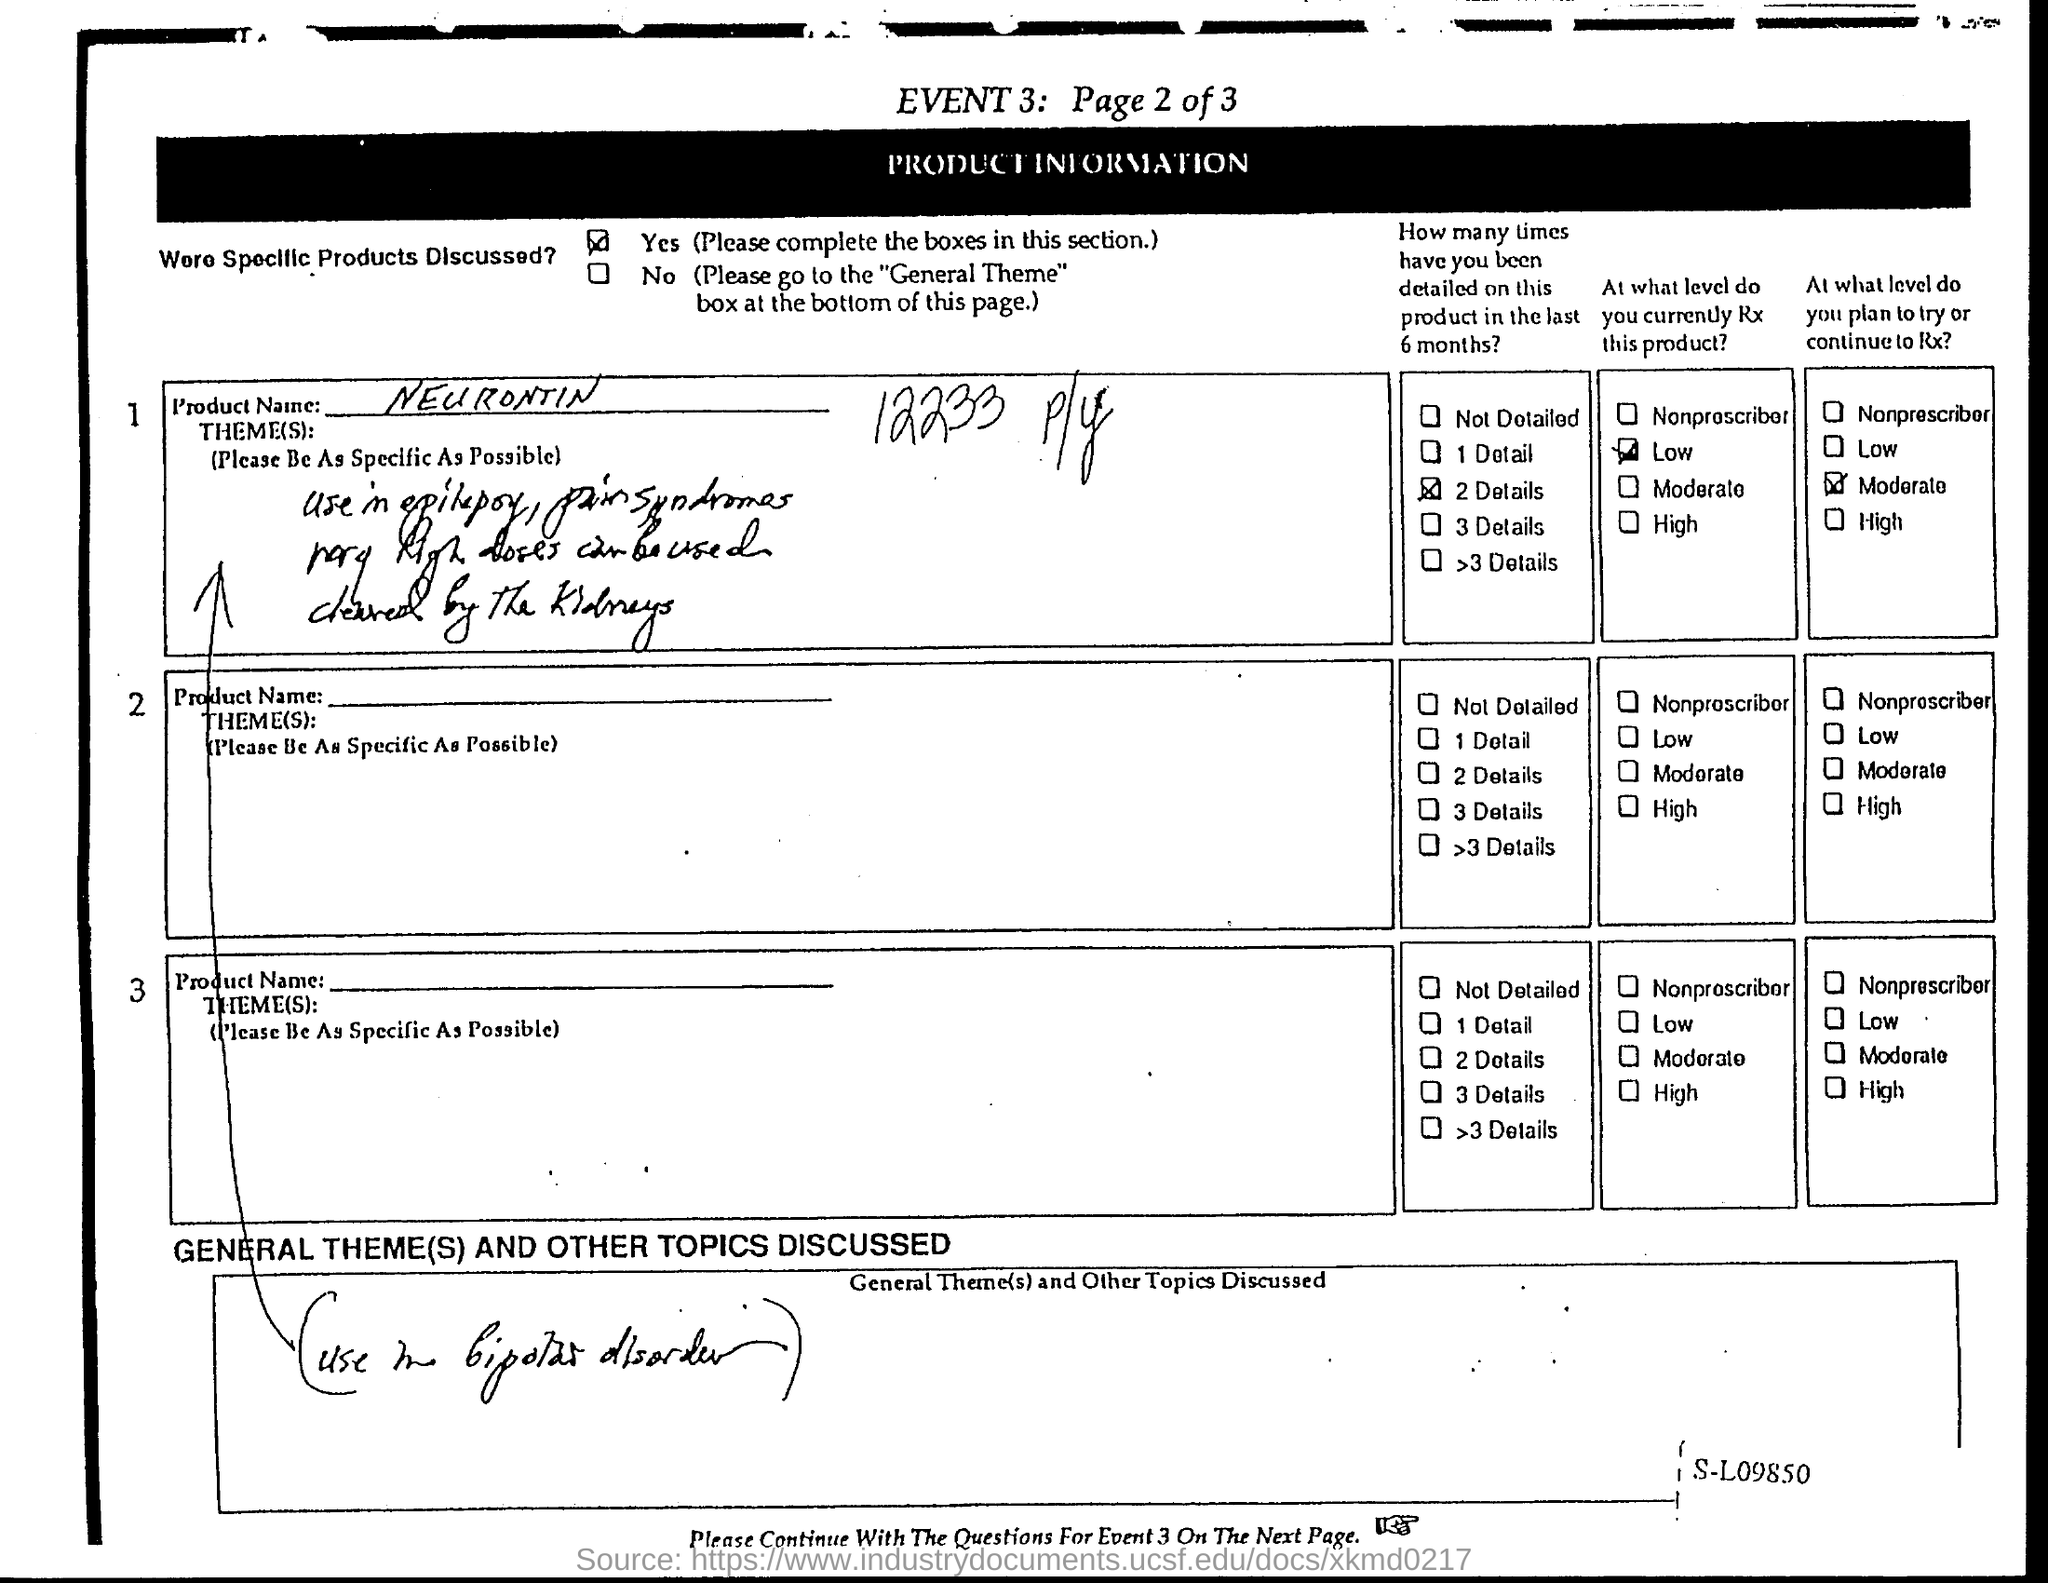Specify some key components in this picture. The product name is Neurontin. 